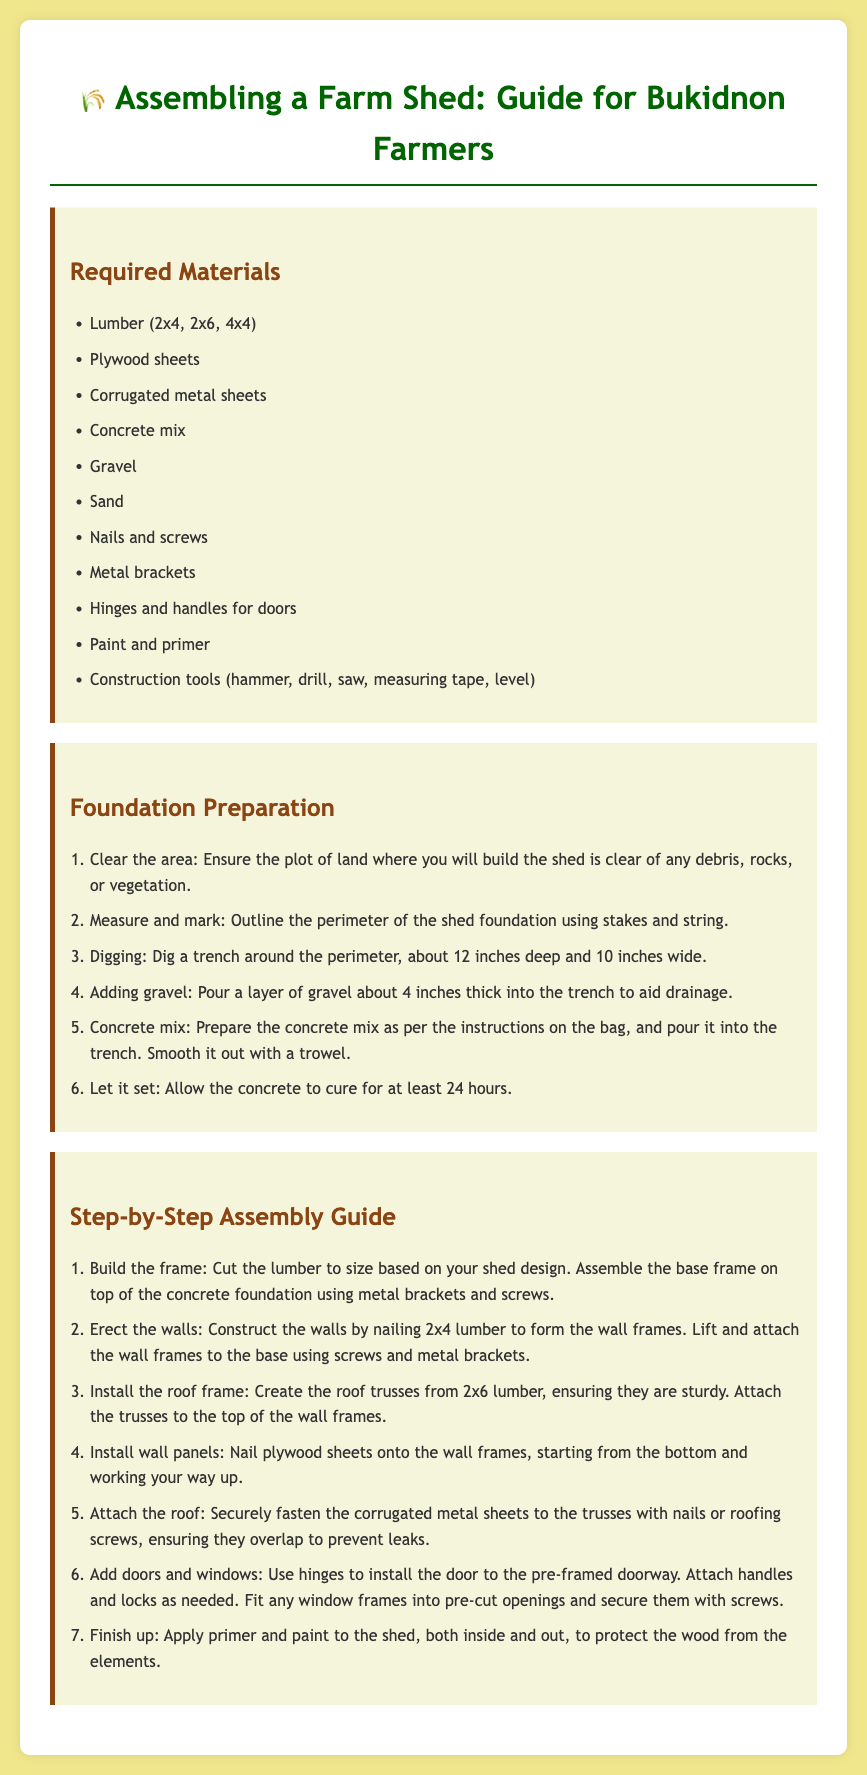what materials are required for the farm shed? The required materials include various types of lumber, plywood sheets, corrugated metal sheets, and several additional items such as nails and paints as listed in the document.
Answer: Lumber, plywood sheets, corrugated metal sheets, concrete mix, gravel, sand, nails and screws, metal brackets, hinges and handles for doors, paint and primer, construction tools how deep should the trench be for the foundation? The document specifies that the trench should be about 12 inches deep and 10 inches wide for the shed foundation.
Answer: 12 inches what step follows adding gravel in foundation preparation? After pouring a layer of gravel about 4 inches thick, the next step is to prepare and pour the concrete mix into the trench.
Answer: Prepare concrete mix how many steps are in the assembly guide? The document outlines seven steps to assemble the farm shed in the step-by-step guide.
Answer: 7 what is the purpose of applying primer and paint? The explanation given indicates that applying primer and paint protects the wood from the elements, which is crucial for the longevity of the shed.
Answer: Protect wood how should the corrugated metal sheets be attached? The document mentions that the corrugated metal sheets should be securely fastened to the trusses with nails or roofing screws, ensuring they overlap.
Answer: With nails or roofing screws what is the first thing to do in the foundation preparation? The first step listed in the foundation preparation section is to clear the area of any debris, rocks, or vegetation before starting construction.
Answer: Clear the area what tools are mentioned as construction tools? The document lists several tools including a hammer, drill, saw, measuring tape, and level necessary for constructing the farm shed.
Answer: Hammer, drill, saw, measuring tape, level what type of lumber is used for erecting walls? The required materials specify that 2x4 lumber is used for constructing the wall frames of the shed.
Answer: 2x4 lumber 